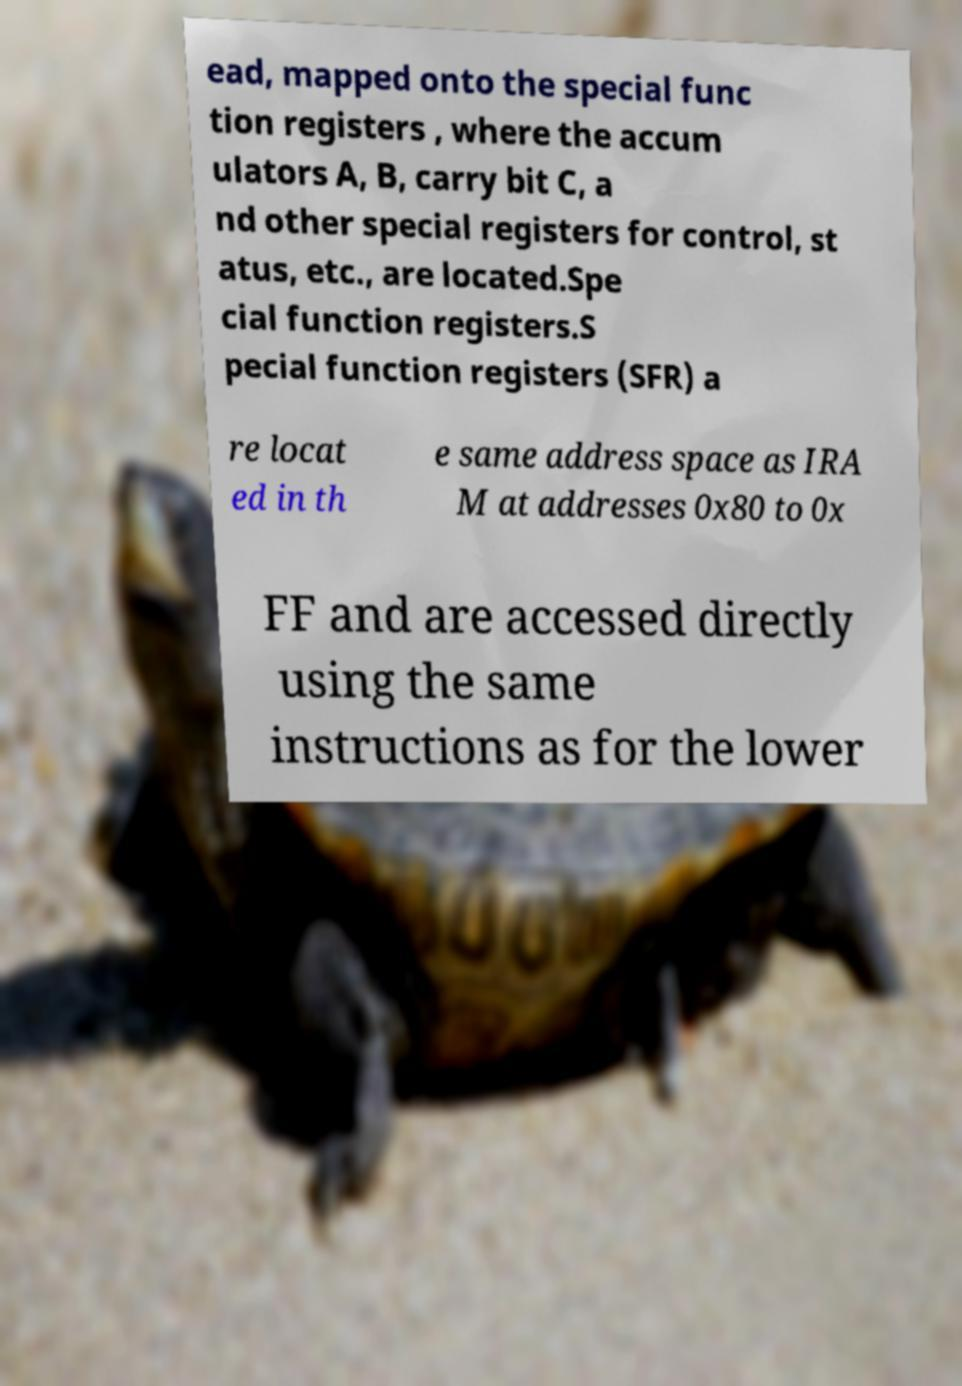Can you read and provide the text displayed in the image?This photo seems to have some interesting text. Can you extract and type it out for me? ead, mapped onto the special func tion registers , where the accum ulators A, B, carry bit C, a nd other special registers for control, st atus, etc., are located.Spe cial function registers.S pecial function registers (SFR) a re locat ed in th e same address space as IRA M at addresses 0x80 to 0x FF and are accessed directly using the same instructions as for the lower 